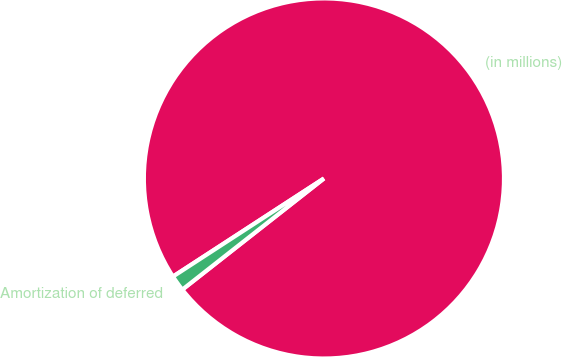Convert chart to OTSL. <chart><loc_0><loc_0><loc_500><loc_500><pie_chart><fcel>(in millions)<fcel>Amortization of deferred<nl><fcel>98.58%<fcel>1.42%<nl></chart> 